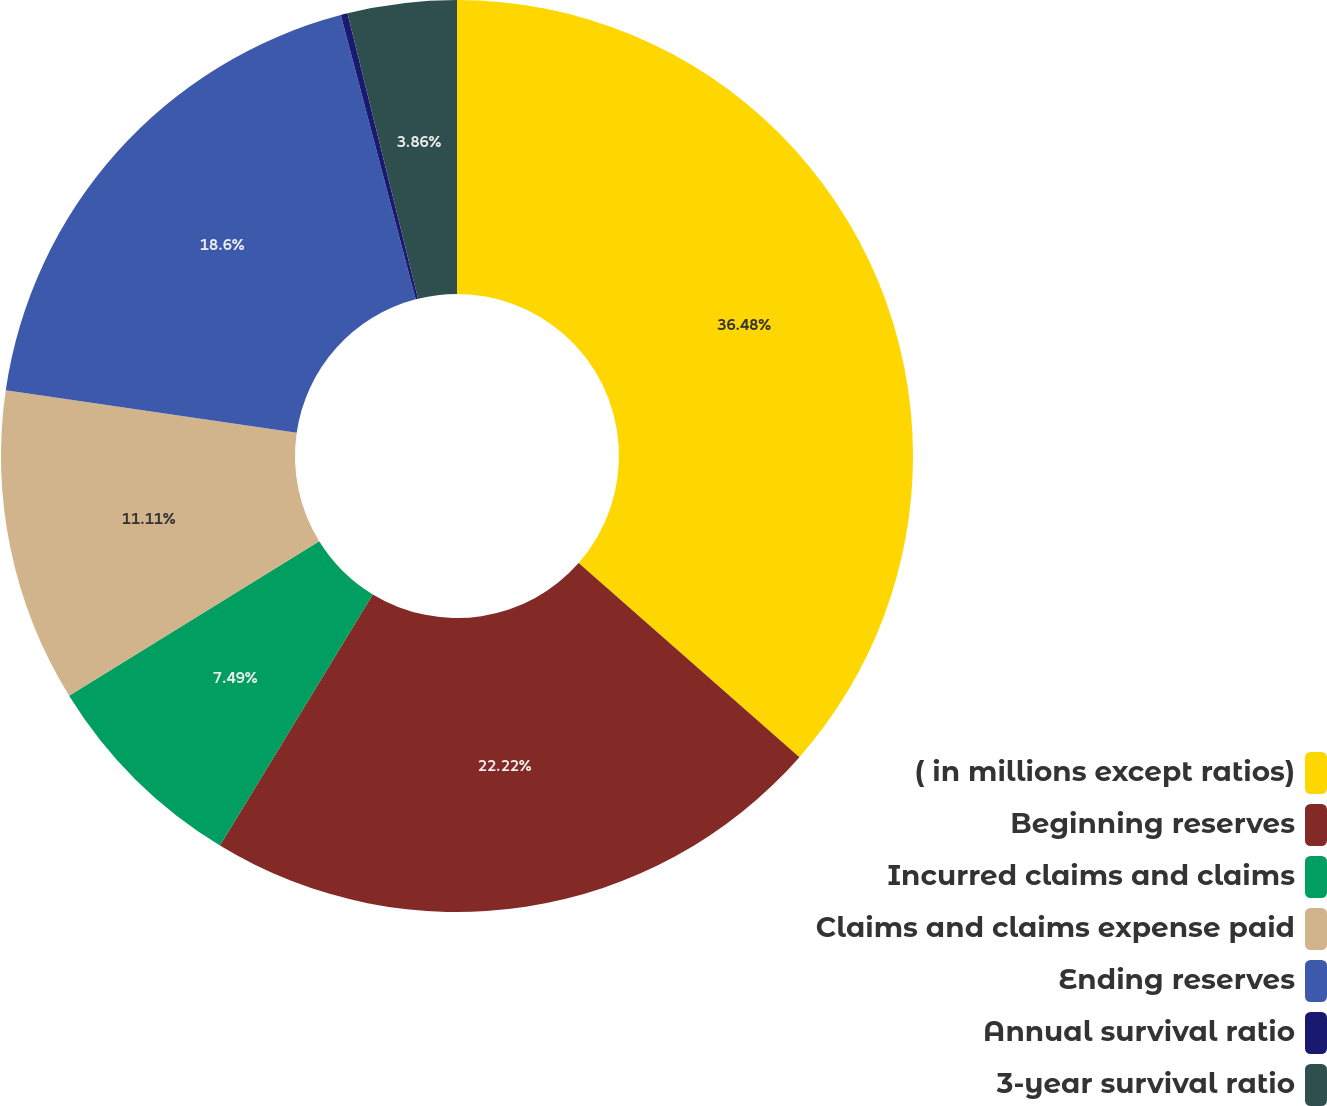Convert chart. <chart><loc_0><loc_0><loc_500><loc_500><pie_chart><fcel>( in millions except ratios)<fcel>Beginning reserves<fcel>Incurred claims and claims<fcel>Claims and claims expense paid<fcel>Ending reserves<fcel>Annual survival ratio<fcel>3-year survival ratio<nl><fcel>36.48%<fcel>22.22%<fcel>7.49%<fcel>11.11%<fcel>18.6%<fcel>0.24%<fcel>3.86%<nl></chart> 